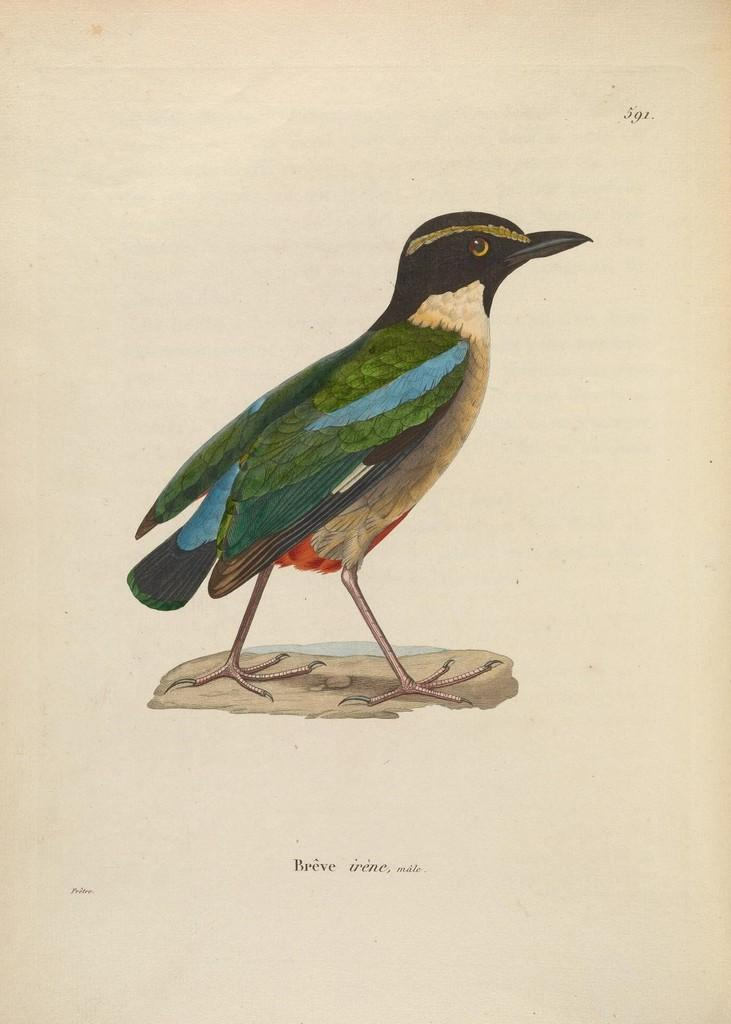What type of animal is in the picture? There is a bird in the picture. Can you describe the bird's appearance? The bird has black and blue feathers. What is the background of the picture? There is a white backdrop in the picture. What type of zephyr can be seen in the picture? There is no zephyr present in the picture; it features a bird with black and blue feathers against a white backdrop. 